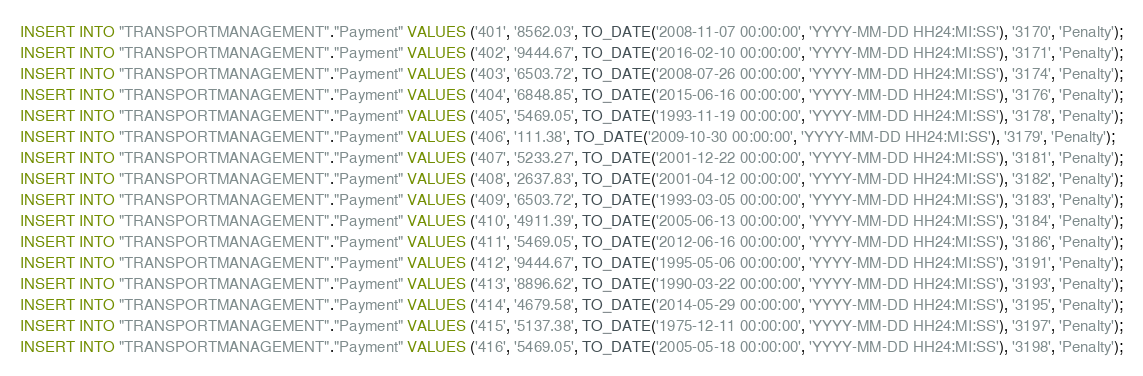<code> <loc_0><loc_0><loc_500><loc_500><_SQL_>INSERT INTO "TRANSPORTMANAGEMENT"."Payment" VALUES ('401', '8562.03', TO_DATE('2008-11-07 00:00:00', 'YYYY-MM-DD HH24:MI:SS'), '3170', 'Penalty');
INSERT INTO "TRANSPORTMANAGEMENT"."Payment" VALUES ('402', '9444.67', TO_DATE('2016-02-10 00:00:00', 'YYYY-MM-DD HH24:MI:SS'), '3171', 'Penalty');
INSERT INTO "TRANSPORTMANAGEMENT"."Payment" VALUES ('403', '6503.72', TO_DATE('2008-07-26 00:00:00', 'YYYY-MM-DD HH24:MI:SS'), '3174', 'Penalty');
INSERT INTO "TRANSPORTMANAGEMENT"."Payment" VALUES ('404', '6848.85', TO_DATE('2015-06-16 00:00:00', 'YYYY-MM-DD HH24:MI:SS'), '3176', 'Penalty');
INSERT INTO "TRANSPORTMANAGEMENT"."Payment" VALUES ('405', '5469.05', TO_DATE('1993-11-19 00:00:00', 'YYYY-MM-DD HH24:MI:SS'), '3178', 'Penalty');
INSERT INTO "TRANSPORTMANAGEMENT"."Payment" VALUES ('406', '111.38', TO_DATE('2009-10-30 00:00:00', 'YYYY-MM-DD HH24:MI:SS'), '3179', 'Penalty');
INSERT INTO "TRANSPORTMANAGEMENT"."Payment" VALUES ('407', '5233.27', TO_DATE('2001-12-22 00:00:00', 'YYYY-MM-DD HH24:MI:SS'), '3181', 'Penalty');
INSERT INTO "TRANSPORTMANAGEMENT"."Payment" VALUES ('408', '2637.83', TO_DATE('2001-04-12 00:00:00', 'YYYY-MM-DD HH24:MI:SS'), '3182', 'Penalty');
INSERT INTO "TRANSPORTMANAGEMENT"."Payment" VALUES ('409', '6503.72', TO_DATE('1993-03-05 00:00:00', 'YYYY-MM-DD HH24:MI:SS'), '3183', 'Penalty');
INSERT INTO "TRANSPORTMANAGEMENT"."Payment" VALUES ('410', '4911.39', TO_DATE('2005-06-13 00:00:00', 'YYYY-MM-DD HH24:MI:SS'), '3184', 'Penalty');
INSERT INTO "TRANSPORTMANAGEMENT"."Payment" VALUES ('411', '5469.05', TO_DATE('2012-06-16 00:00:00', 'YYYY-MM-DD HH24:MI:SS'), '3186', 'Penalty');
INSERT INTO "TRANSPORTMANAGEMENT"."Payment" VALUES ('412', '9444.67', TO_DATE('1995-05-06 00:00:00', 'YYYY-MM-DD HH24:MI:SS'), '3191', 'Penalty');
INSERT INTO "TRANSPORTMANAGEMENT"."Payment" VALUES ('413', '8896.62', TO_DATE('1990-03-22 00:00:00', 'YYYY-MM-DD HH24:MI:SS'), '3193', 'Penalty');
INSERT INTO "TRANSPORTMANAGEMENT"."Payment" VALUES ('414', '4679.58', TO_DATE('2014-05-29 00:00:00', 'YYYY-MM-DD HH24:MI:SS'), '3195', 'Penalty');
INSERT INTO "TRANSPORTMANAGEMENT"."Payment" VALUES ('415', '5137.38', TO_DATE('1975-12-11 00:00:00', 'YYYY-MM-DD HH24:MI:SS'), '3197', 'Penalty');
INSERT INTO "TRANSPORTMANAGEMENT"."Payment" VALUES ('416', '5469.05', TO_DATE('2005-05-18 00:00:00', 'YYYY-MM-DD HH24:MI:SS'), '3198', 'Penalty');</code> 